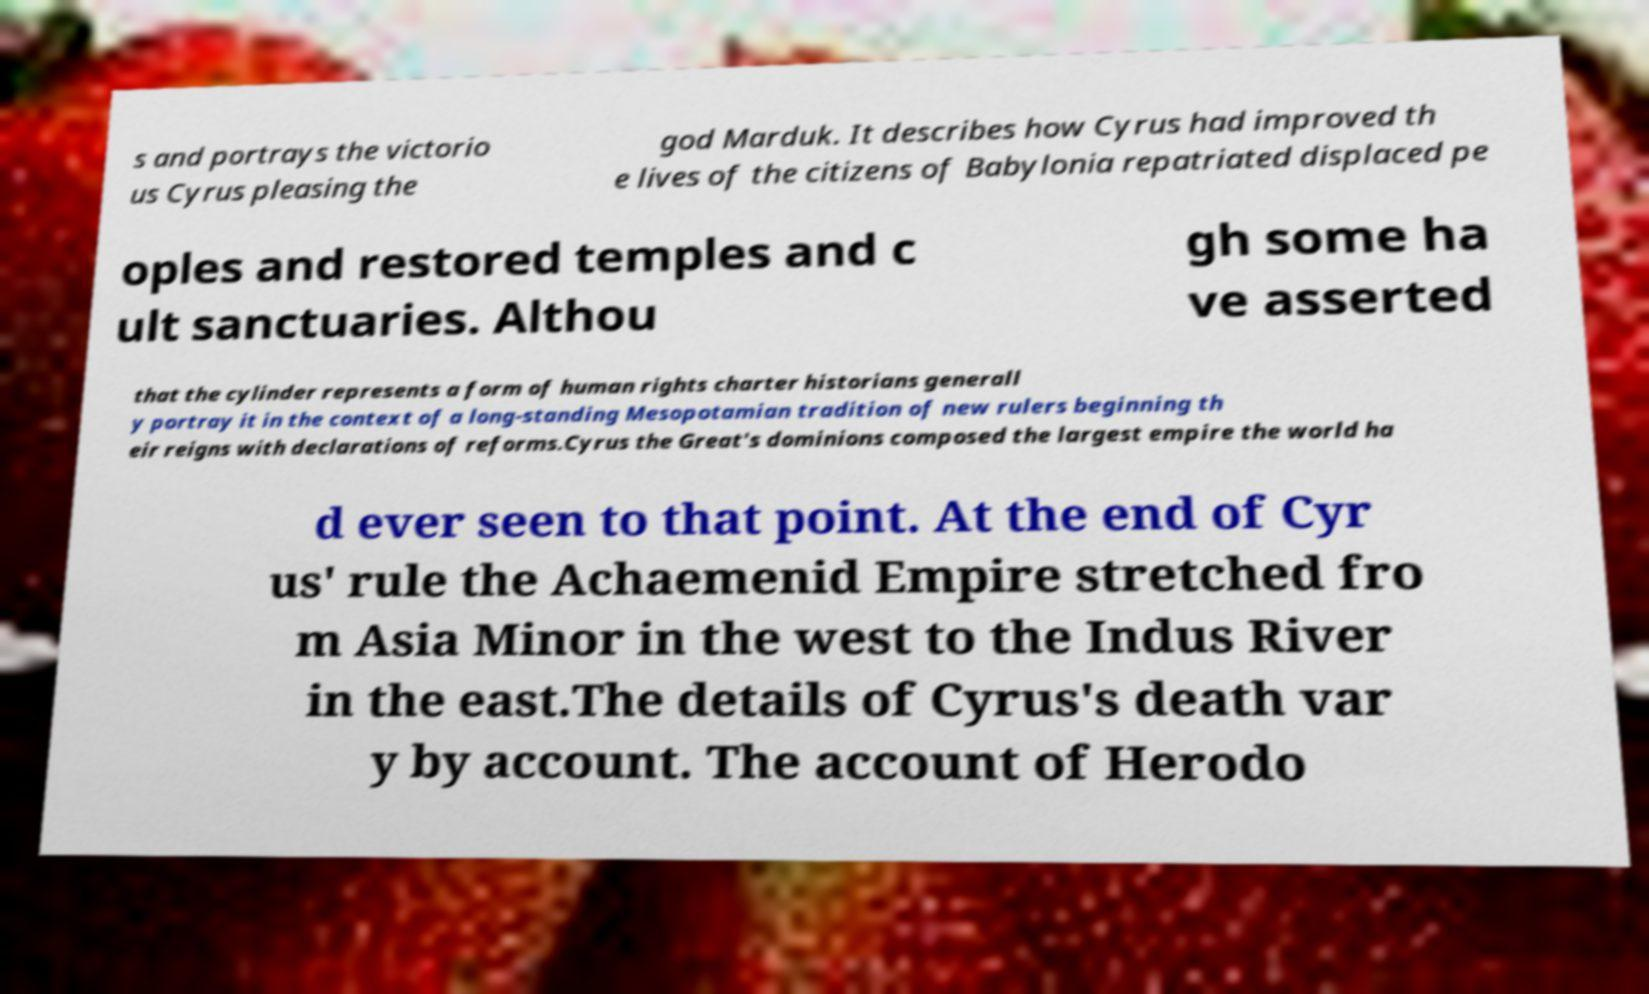Can you accurately transcribe the text from the provided image for me? s and portrays the victorio us Cyrus pleasing the god Marduk. It describes how Cyrus had improved th e lives of the citizens of Babylonia repatriated displaced pe oples and restored temples and c ult sanctuaries. Althou gh some ha ve asserted that the cylinder represents a form of human rights charter historians generall y portray it in the context of a long-standing Mesopotamian tradition of new rulers beginning th eir reigns with declarations of reforms.Cyrus the Great's dominions composed the largest empire the world ha d ever seen to that point. At the end of Cyr us' rule the Achaemenid Empire stretched fro m Asia Minor in the west to the Indus River in the east.The details of Cyrus's death var y by account. The account of Herodo 